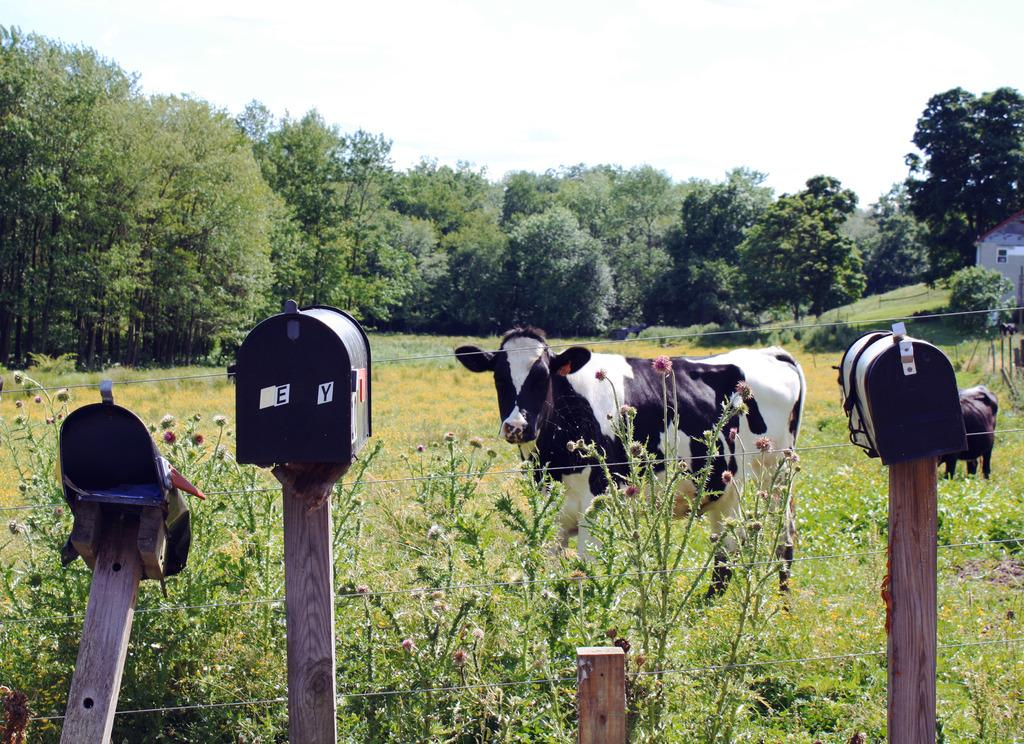What animal is present in the image? There is a cow in the image. Where is the cow located? The cow is standing in the grass. What can be seen in the background of the image? There is a fence, trees, and a shed in the image. What type of error can be seen in the image? There is no error present in the image; it is a clear photograph of a cow standing in the grass. 